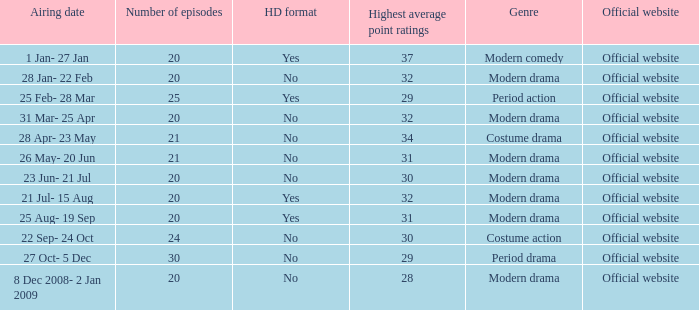What was the broadcast date when the episode count exceeded 20 and featured the genre of period action? 22 Sep- 24 Oct. 